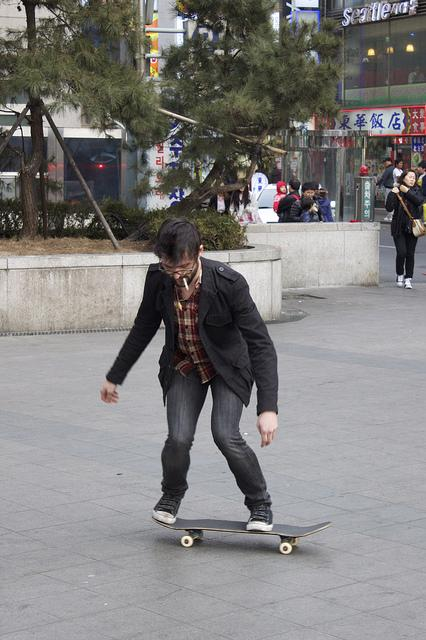What part of his body will be most harmed by the item in his mouth? Please explain your reasoning. lungs. Inhaling heated smoke causes tissue damage 